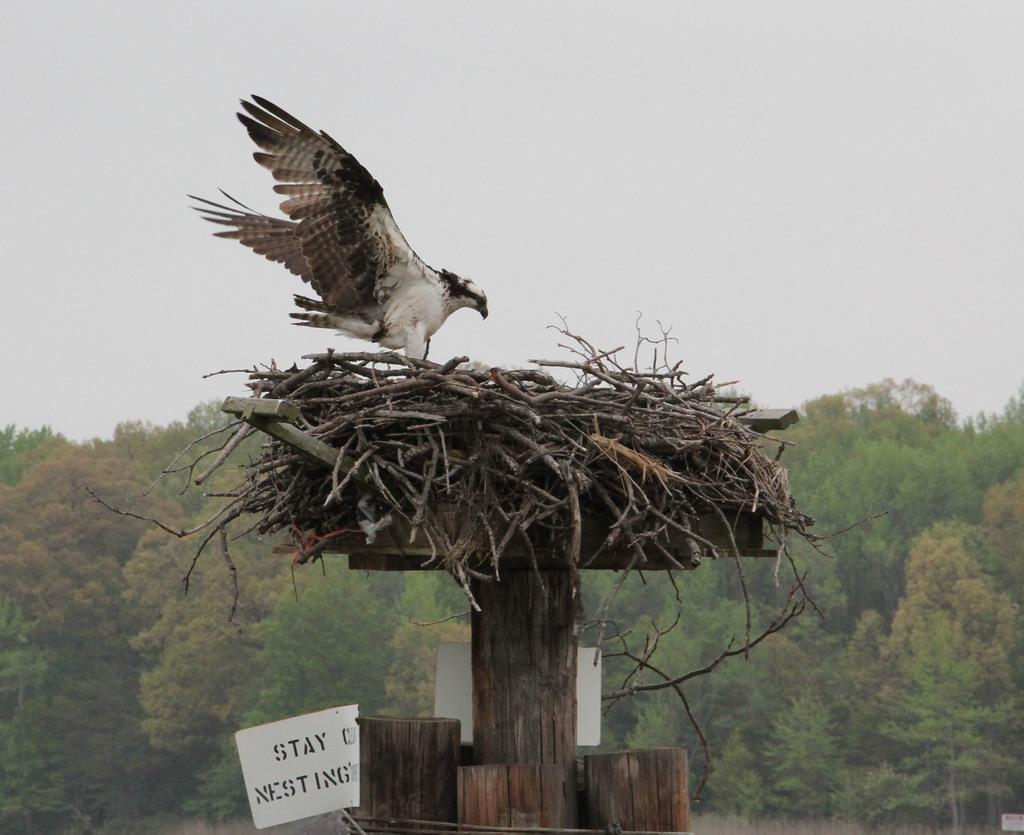Could you give a brief overview of what you see in this image? In the middle of the image there are wooden poles. On the poles there is a nest. On the nest there is a bird standing. And also there is a paper with something written on it. In the background there are trees. At the top of the image there is sky.  